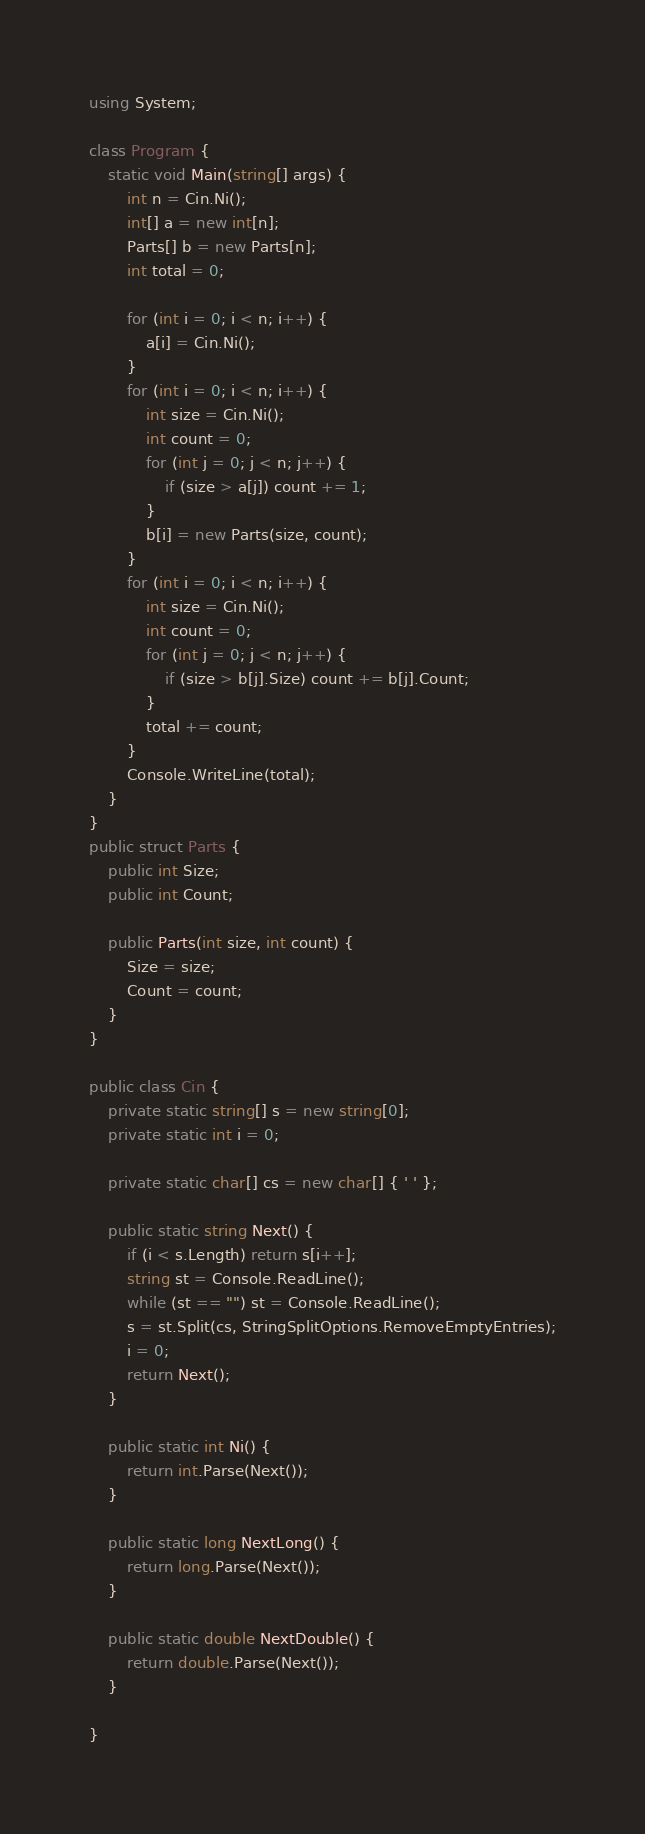<code> <loc_0><loc_0><loc_500><loc_500><_C#_>using System;

class Program {
    static void Main(string[] args) {
        int n = Cin.Ni();
        int[] a = new int[n];
        Parts[] b = new Parts[n];
        int total = 0;

        for (int i = 0; i < n; i++) {
            a[i] = Cin.Ni();
        }
        for (int i = 0; i < n; i++) {
            int size = Cin.Ni();
            int count = 0;
            for (int j = 0; j < n; j++) {
                if (size > a[j]) count += 1;
            }
            b[i] = new Parts(size, count);
        }
        for (int i = 0; i < n; i++) {
            int size = Cin.Ni();
            int count = 0;
            for (int j = 0; j < n; j++) {
                if (size > b[j].Size) count += b[j].Count;
            }
            total += count;
        }
        Console.WriteLine(total);
    }
}
public struct Parts {
    public int Size;
    public int Count;

    public Parts(int size, int count) {
        Size = size;
        Count = count;
    }
}

public class Cin {
    private static string[] s = new string[0];
    private static int i = 0;

    private static char[] cs = new char[] { ' ' };

    public static string Next() {
        if (i < s.Length) return s[i++];
        string st = Console.ReadLine();
        while (st == "") st = Console.ReadLine();
        s = st.Split(cs, StringSplitOptions.RemoveEmptyEntries);
        i = 0;
        return Next();
    }

    public static int Ni() {
        return int.Parse(Next());
    }

    public static long NextLong() {
        return long.Parse(Next());
    }

    public static double NextDouble() {
        return double.Parse(Next());
    }

}
</code> 